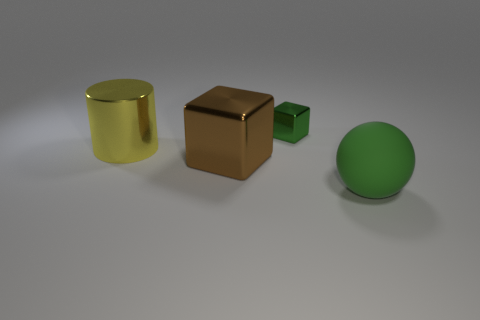Is there anything else that has the same size as the green metal thing?
Offer a very short reply. No. There is a ball that is the same color as the small object; what is its size?
Make the answer very short. Large. The large thing that is made of the same material as the cylinder is what color?
Your response must be concise. Brown. Are the large block and the green object that is in front of the large yellow cylinder made of the same material?
Provide a succinct answer. No. What is the color of the big matte object?
Provide a succinct answer. Green. What is the size of the brown object that is the same material as the large cylinder?
Your response must be concise. Large. There is a metal block that is on the left side of the green thing behind the large rubber thing; what number of metal things are on the right side of it?
Give a very brief answer. 1. There is a small metal object; does it have the same color as the object in front of the brown object?
Make the answer very short. Yes. What is the shape of the tiny object that is the same color as the large ball?
Provide a succinct answer. Cube. The block on the left side of the green object that is behind the big metallic cylinder left of the big block is made of what material?
Offer a very short reply. Metal. 